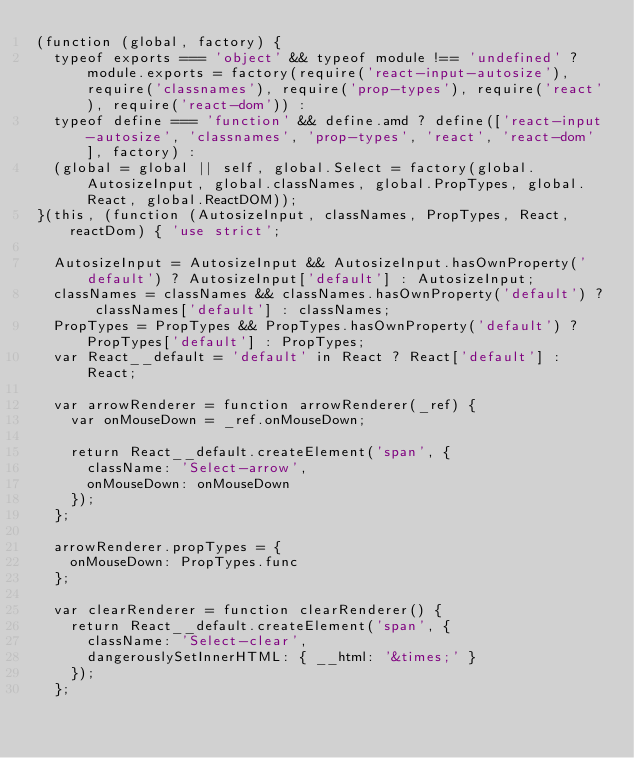<code> <loc_0><loc_0><loc_500><loc_500><_JavaScript_>(function (global, factory) {
	typeof exports === 'object' && typeof module !== 'undefined' ? module.exports = factory(require('react-input-autosize'), require('classnames'), require('prop-types'), require('react'), require('react-dom')) :
	typeof define === 'function' && define.amd ? define(['react-input-autosize', 'classnames', 'prop-types', 'react', 'react-dom'], factory) :
	(global = global || self, global.Select = factory(global.AutosizeInput, global.classNames, global.PropTypes, global.React, global.ReactDOM));
}(this, (function (AutosizeInput, classNames, PropTypes, React, reactDom) { 'use strict';

	AutosizeInput = AutosizeInput && AutosizeInput.hasOwnProperty('default') ? AutosizeInput['default'] : AutosizeInput;
	classNames = classNames && classNames.hasOwnProperty('default') ? classNames['default'] : classNames;
	PropTypes = PropTypes && PropTypes.hasOwnProperty('default') ? PropTypes['default'] : PropTypes;
	var React__default = 'default' in React ? React['default'] : React;

	var arrowRenderer = function arrowRenderer(_ref) {
		var onMouseDown = _ref.onMouseDown;

		return React__default.createElement('span', {
			className: 'Select-arrow',
			onMouseDown: onMouseDown
		});
	};

	arrowRenderer.propTypes = {
		onMouseDown: PropTypes.func
	};

	var clearRenderer = function clearRenderer() {
		return React__default.createElement('span', {
			className: 'Select-clear',
			dangerouslySetInnerHTML: { __html: '&times;' }
		});
	};
</code> 